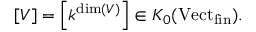<formula> <loc_0><loc_0><loc_500><loc_500>[ V ] = \left [ k ^ { \dim ( V ) } \right ] \in K _ { 0 } ( V e c t _ { f i n } ) .</formula> 